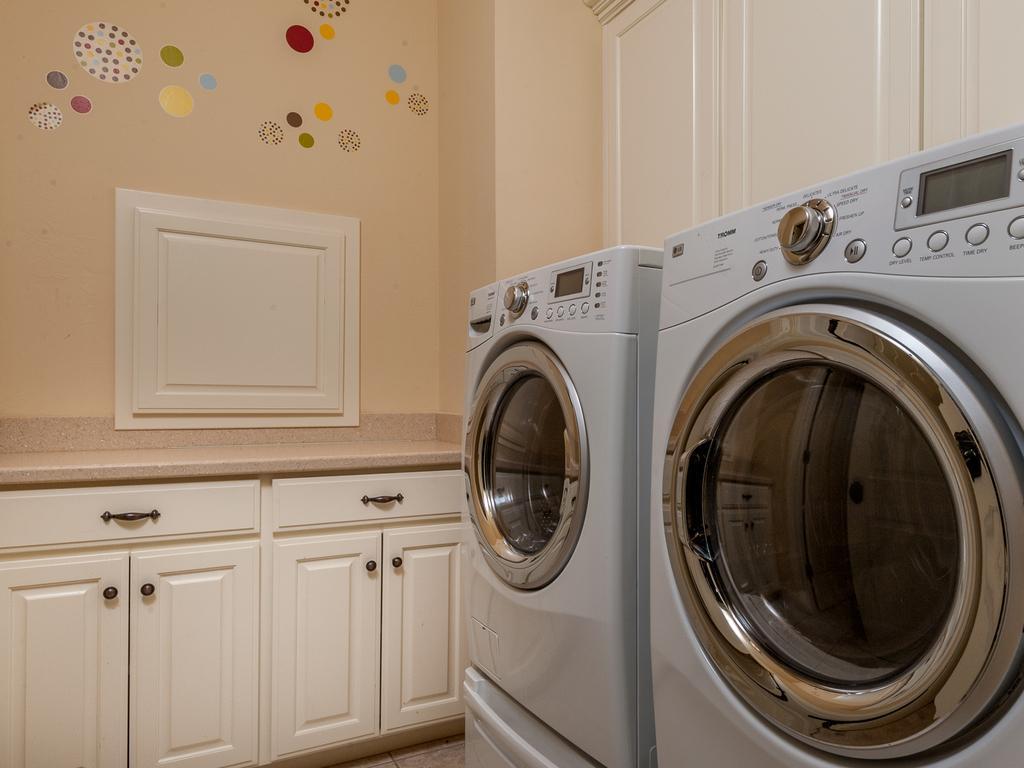Could you give a brief overview of what you see in this image? In this image we can see two washing machines. In the back there is a platform with cupboards. In the background there is a wall with designs. 